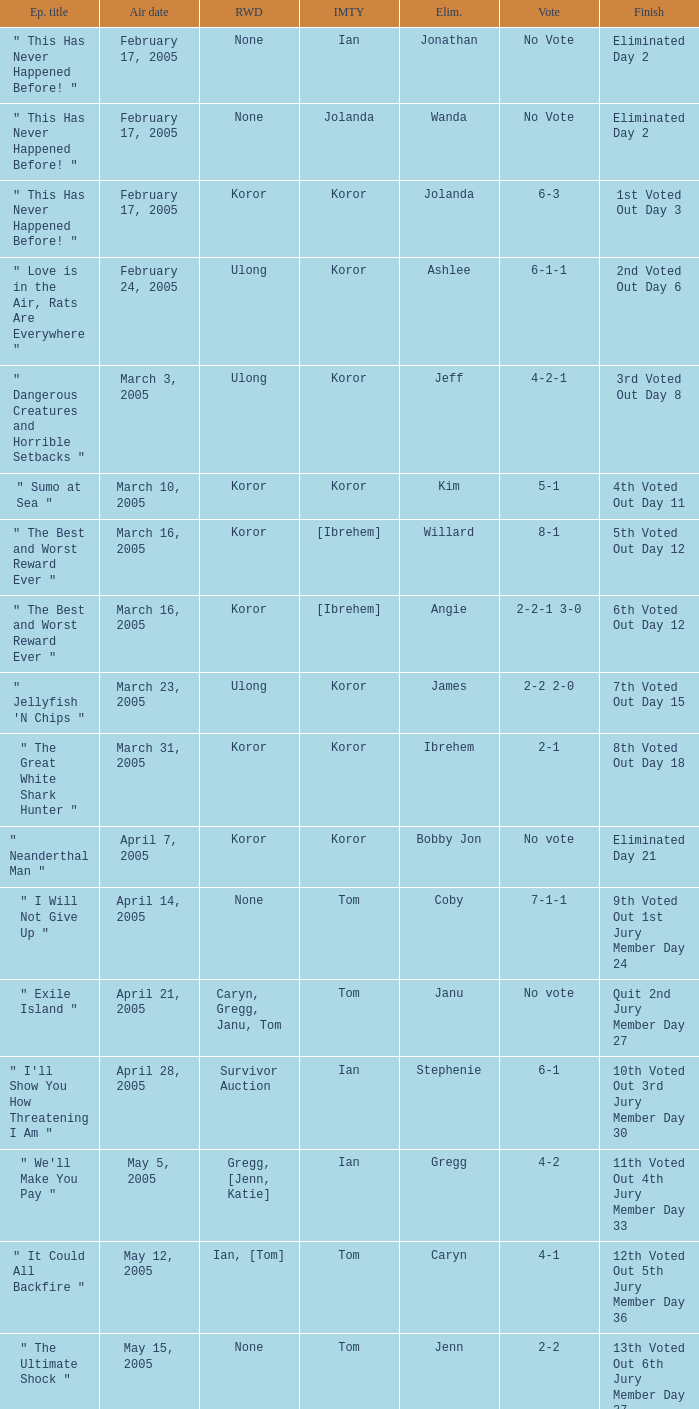What was the vote on the episode where the finish was "10th voted out 3rd jury member day 30"? 6-1. 